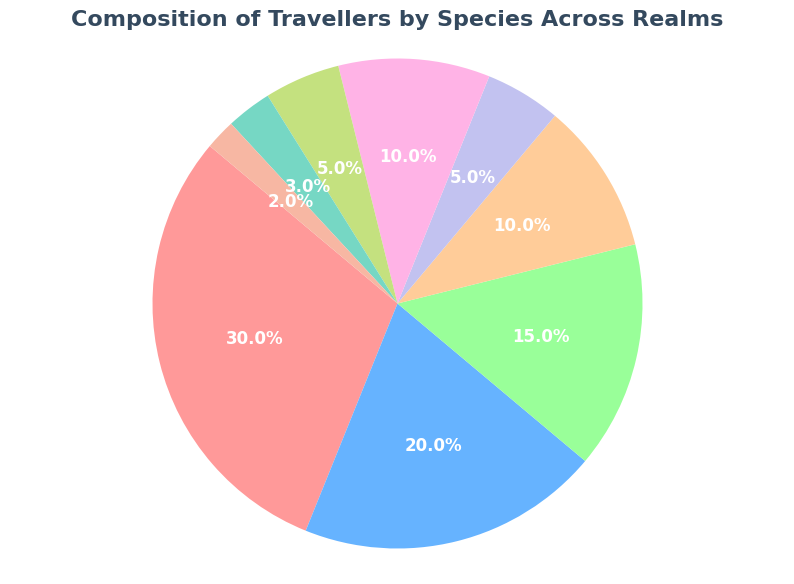Which species has the highest percentage of travelers? From the pie chart, the slice representing Humans is the largest. The text within the Humans' slice shows a value of 30%.
Answer: Humans Which two species have the same percentage of travelers? By examining the slices of the pie chart, both Orcs and Fae have a 10% slice.
Answer: Orcs and Fae What is the total percentage of travelers that are non-human species? To find the total percentage of travelers that are non-human species, add the percentages of all species other than Humans: 20% (Elves) + 15% (Dwarves) + 10% (Orcs) + 5% (Dragons) + 10% (Fae) + 5% (Merfolk) + 3% (Elementals) + 2% (Vampires) = 70%.
Answer: 70% How does the percentage of Dwarves compare with that of Elves? From the pie chart, the percentage for Dwarves is 15% and for Elves is 20%. Since 20% is greater than 15%, Elves have a higher percentage than Dwarves.
Answer: Elves have a higher percentage If we combine the percentage of Merfolk and Vampires, does it equal the percentage of Dragons? The percentage for Merfolk is 5% and for Vampires is 2%. Adding these together, 5% + 2% = 7%, which is greater than the percentage for Dragons (5%).
Answer: No What is the proportion of Elementals compared to the total non-elemental traveling species? The percentage for Elementals is 3%. To find the proportion, we first calculate the total percentage of non-elemental species: 100% - 3% = 97%. The proportion is then 3% / 97% ≈ 0.031, which is approximately 3.1%.
Answer: Approximately 3.1% Which species has the smallest slice on the pie chart? By identifying the smallest slice visually, it is the one labeled as Vampires, with a percentage of 2%.
Answer: Vampires What is the sum percentage of Elves, Dwarves, and Orcs? Add the percentages for Elves, Dwarves, and Orcs: 20% + 15% + 10% = 45%.
Answer: 45% 